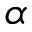Convert formula to latex. <formula><loc_0><loc_0><loc_500><loc_500>\alpha</formula> 